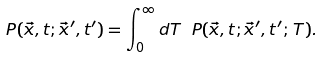Convert formula to latex. <formula><loc_0><loc_0><loc_500><loc_500>P ( \vec { x } , t ; \vec { x } ^ { \prime } , t ^ { \prime } ) = \int _ { 0 } ^ { \infty } d T \ P ( \vec { x } , t ; \vec { x } ^ { \prime } , t ^ { \prime } ; \, T ) .</formula> 